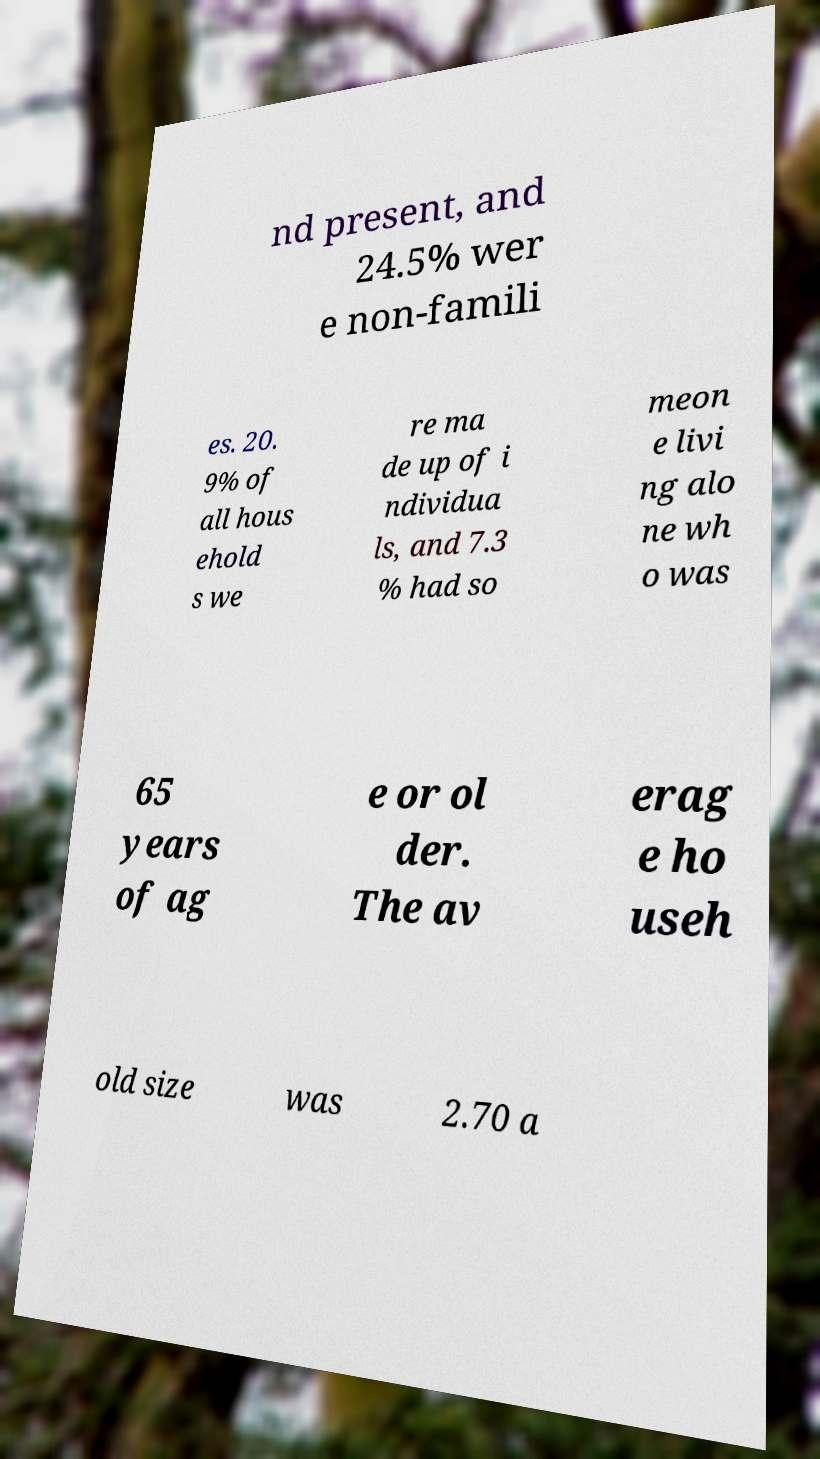What messages or text are displayed in this image? I need them in a readable, typed format. nd present, and 24.5% wer e non-famili es. 20. 9% of all hous ehold s we re ma de up of i ndividua ls, and 7.3 % had so meon e livi ng alo ne wh o was 65 years of ag e or ol der. The av erag e ho useh old size was 2.70 a 